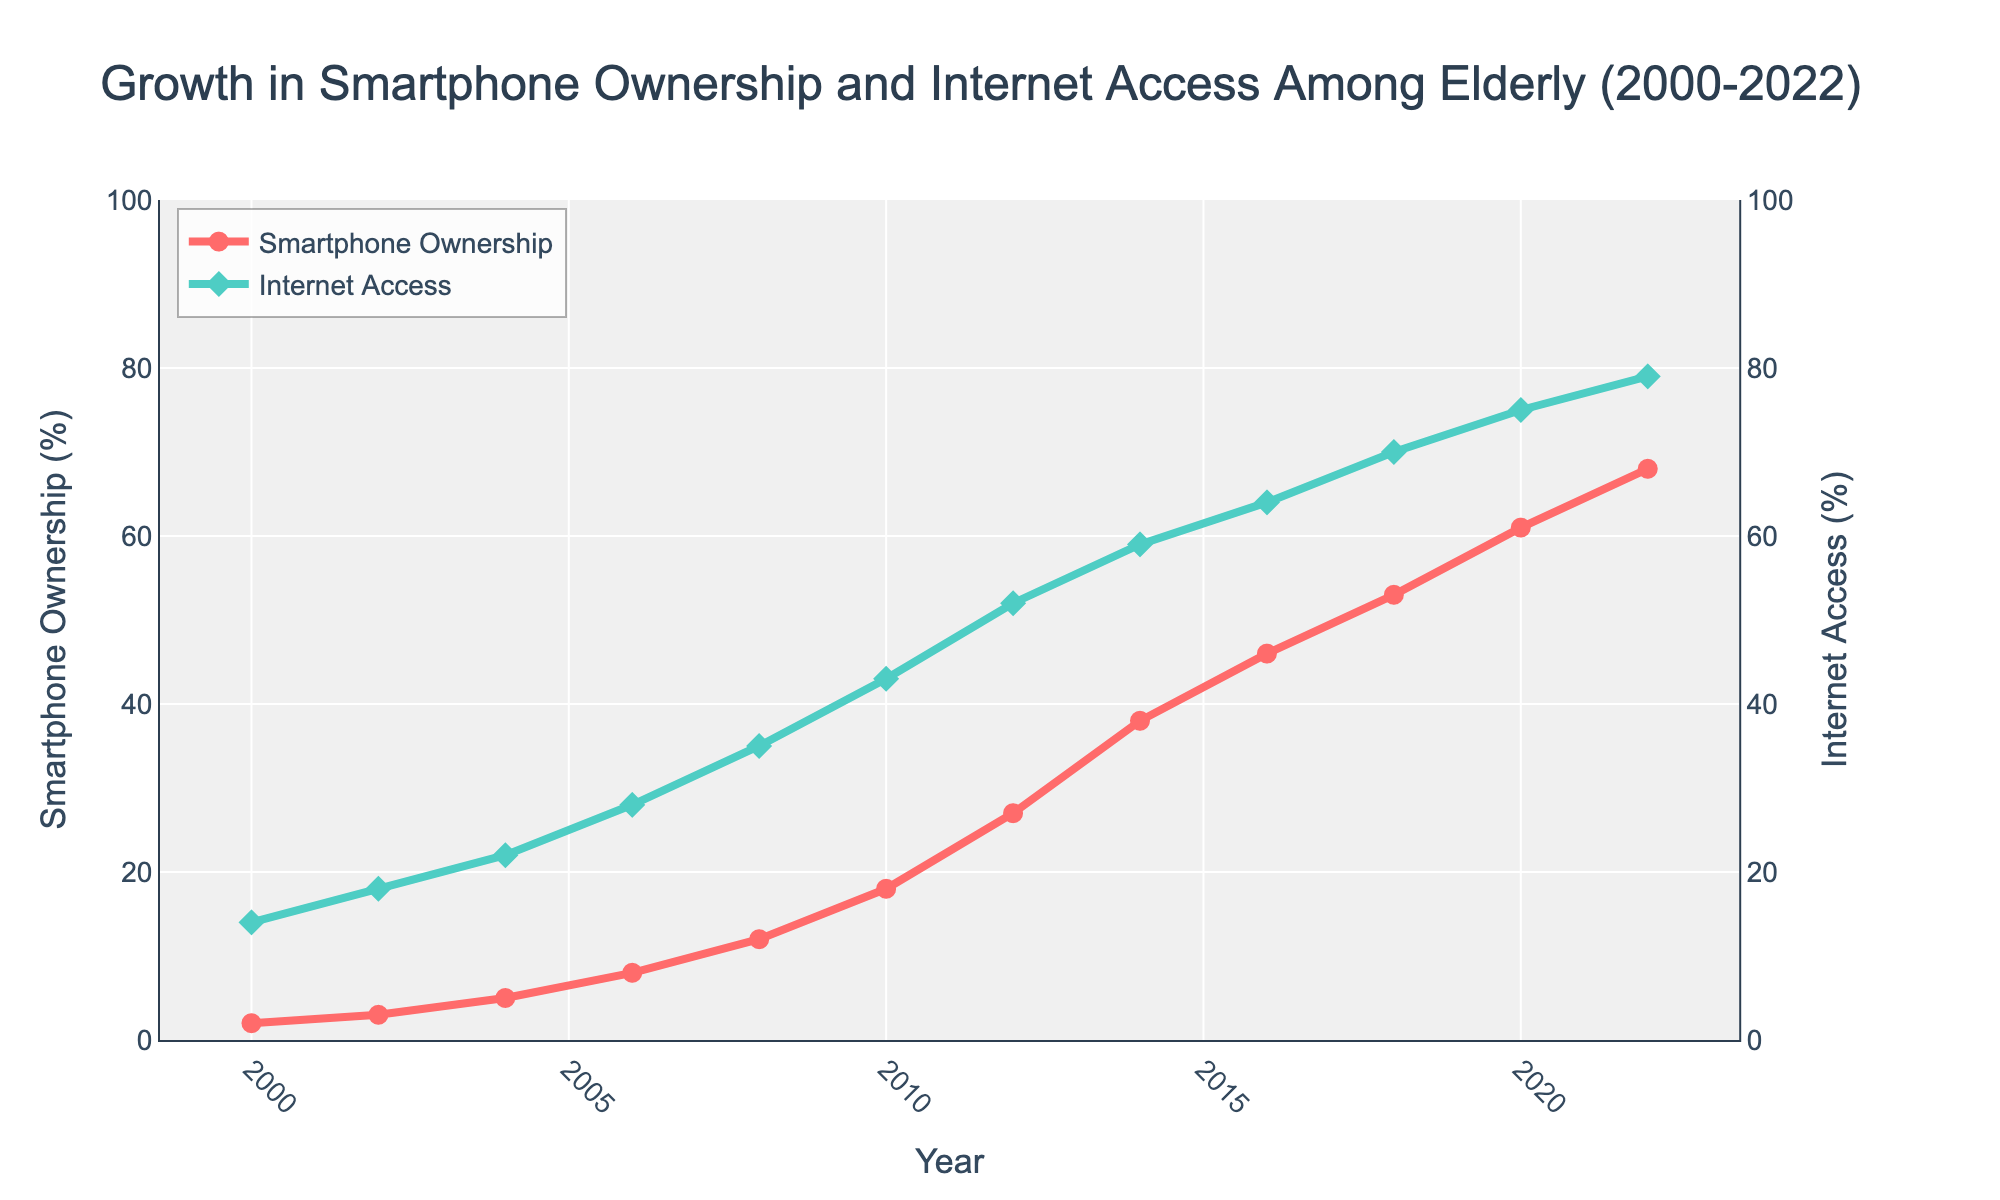What was the percentage increase in smartphone ownership from 2000 to 2022? To find the percentage increase, subtract the initial percentage in 2000 from the final percentage in 2022, then divide by the initial percentage and multiply by 100. This can be expressed as ((68-2)/2)*100. Calculating gives (66/2)*100 = 3300%
Answer: 3300% In which year did smartphone ownership surpass 50% among the elderly? Locate the point on the line chart where the smartphone ownership percentage first exceeds 50%. According to the chart, this occurs in 2018
Answer: 2018 Which has a steeper growth trend throughout the period, smartphone ownership or internet access? To determine the steeper growth trend, compare the overall rise in percentage points for both metrics from 2000 to 2022. Smartphone ownership increased from 2% to 68% (66 percentage points) while internet access increased from 14% to 79% (65 percentage points). Both have similar rates, but smartphone ownership had a slight edge in percentage points growth.
Answer: Smartphone ownership During which period did internet access see the highest growth rate? To find the highest growth rate, examine the steepness of the plot lines for different periods. The interval from 2008 to 2010 shows a significant rise from 35% to 43%, an 8 percentage point increase over just 2 years (approximately 22.86% increase)
Answer: 2008-2010 By how many percentage points did smartphone ownership increase every 4 years on average? To calculate the average increase every 4 years, divide the total increase in smartphone ownership (68-2 = 66 percentage points) by the number of 4-year intervals (22/4 = 5.5). So, 66/5.5 equals approximately 12 percentage points every 4 years
Answer: 12 percentage points Which year shows a greater percentage of elderly internet users compared to smartphone owners? Compare internet access and smartphone ownership percentages year by year. For every year up to 2022, internet access rates are higher than smartphone ownership rates
Answer: Every year What was the difference in internet access between 2014 and 2018? Subtract the internet access percentage in 2014 from the percentage in 2018. This yields 70% - 59% = 11%
Answer: 11% Is there any year where smartphone ownership exactly doubled compared to its value in a previous year? Checking the values, smartphone ownership doubles or more between 2004 (5%) and 2008 (12%), and the same happens between 2008 (12%) and 2014 (27%)
Answer: Yes, between 2004-2008 and 2008-2014 